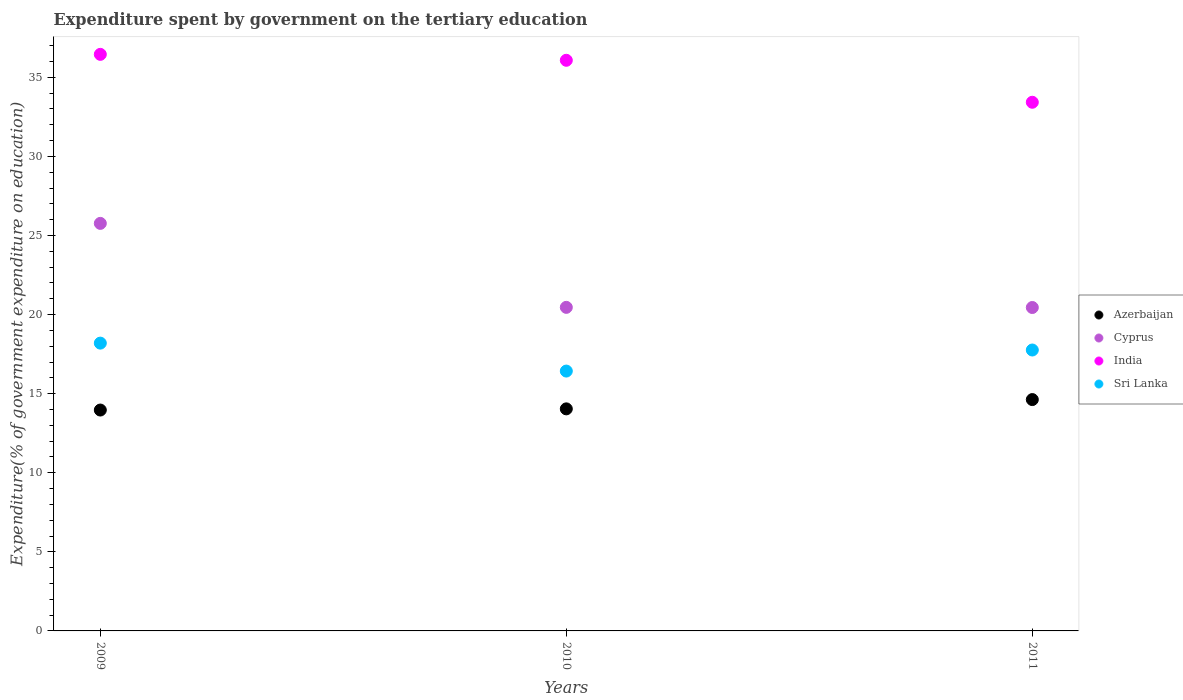Is the number of dotlines equal to the number of legend labels?
Offer a very short reply. Yes. What is the expenditure spent by government on the tertiary education in India in 2009?
Offer a very short reply. 36.45. Across all years, what is the maximum expenditure spent by government on the tertiary education in India?
Your answer should be compact. 36.45. Across all years, what is the minimum expenditure spent by government on the tertiary education in India?
Give a very brief answer. 33.42. In which year was the expenditure spent by government on the tertiary education in Azerbaijan maximum?
Provide a succinct answer. 2011. What is the total expenditure spent by government on the tertiary education in Cyprus in the graph?
Your answer should be compact. 66.67. What is the difference between the expenditure spent by government on the tertiary education in India in 2009 and that in 2010?
Provide a succinct answer. 0.37. What is the difference between the expenditure spent by government on the tertiary education in Azerbaijan in 2011 and the expenditure spent by government on the tertiary education in India in 2010?
Make the answer very short. -21.45. What is the average expenditure spent by government on the tertiary education in Azerbaijan per year?
Ensure brevity in your answer.  14.21. In the year 2009, what is the difference between the expenditure spent by government on the tertiary education in Azerbaijan and expenditure spent by government on the tertiary education in Sri Lanka?
Provide a short and direct response. -4.23. In how many years, is the expenditure spent by government on the tertiary education in Cyprus greater than 6 %?
Your answer should be very brief. 3. What is the ratio of the expenditure spent by government on the tertiary education in Cyprus in 2009 to that in 2010?
Provide a succinct answer. 1.26. What is the difference between the highest and the second highest expenditure spent by government on the tertiary education in India?
Ensure brevity in your answer.  0.37. What is the difference between the highest and the lowest expenditure spent by government on the tertiary education in Azerbaijan?
Your answer should be very brief. 0.66. Is the sum of the expenditure spent by government on the tertiary education in Cyprus in 2009 and 2010 greater than the maximum expenditure spent by government on the tertiary education in Sri Lanka across all years?
Your answer should be compact. Yes. Is it the case that in every year, the sum of the expenditure spent by government on the tertiary education in Azerbaijan and expenditure spent by government on the tertiary education in Sri Lanka  is greater than the expenditure spent by government on the tertiary education in Cyprus?
Offer a very short reply. Yes. Does the expenditure spent by government on the tertiary education in India monotonically increase over the years?
Offer a terse response. No. Does the graph contain any zero values?
Your response must be concise. No. Does the graph contain grids?
Your answer should be very brief. No. What is the title of the graph?
Ensure brevity in your answer.  Expenditure spent by government on the tertiary education. What is the label or title of the X-axis?
Your response must be concise. Years. What is the label or title of the Y-axis?
Ensure brevity in your answer.  Expenditure(% of government expenditure on education). What is the Expenditure(% of government expenditure on education) in Azerbaijan in 2009?
Offer a very short reply. 13.96. What is the Expenditure(% of government expenditure on education) in Cyprus in 2009?
Offer a terse response. 25.77. What is the Expenditure(% of government expenditure on education) in India in 2009?
Provide a succinct answer. 36.45. What is the Expenditure(% of government expenditure on education) of Sri Lanka in 2009?
Make the answer very short. 18.19. What is the Expenditure(% of government expenditure on education) of Azerbaijan in 2010?
Keep it short and to the point. 14.04. What is the Expenditure(% of government expenditure on education) of Cyprus in 2010?
Make the answer very short. 20.46. What is the Expenditure(% of government expenditure on education) in India in 2010?
Offer a terse response. 36.08. What is the Expenditure(% of government expenditure on education) in Sri Lanka in 2010?
Your answer should be very brief. 16.43. What is the Expenditure(% of government expenditure on education) of Azerbaijan in 2011?
Provide a succinct answer. 14.63. What is the Expenditure(% of government expenditure on education) in Cyprus in 2011?
Your response must be concise. 20.45. What is the Expenditure(% of government expenditure on education) in India in 2011?
Your answer should be very brief. 33.42. What is the Expenditure(% of government expenditure on education) of Sri Lanka in 2011?
Offer a terse response. 17.76. Across all years, what is the maximum Expenditure(% of government expenditure on education) in Azerbaijan?
Offer a very short reply. 14.63. Across all years, what is the maximum Expenditure(% of government expenditure on education) of Cyprus?
Make the answer very short. 25.77. Across all years, what is the maximum Expenditure(% of government expenditure on education) of India?
Give a very brief answer. 36.45. Across all years, what is the maximum Expenditure(% of government expenditure on education) in Sri Lanka?
Your answer should be compact. 18.19. Across all years, what is the minimum Expenditure(% of government expenditure on education) of Azerbaijan?
Offer a terse response. 13.96. Across all years, what is the minimum Expenditure(% of government expenditure on education) in Cyprus?
Your response must be concise. 20.45. Across all years, what is the minimum Expenditure(% of government expenditure on education) in India?
Your answer should be very brief. 33.42. Across all years, what is the minimum Expenditure(% of government expenditure on education) in Sri Lanka?
Give a very brief answer. 16.43. What is the total Expenditure(% of government expenditure on education) of Azerbaijan in the graph?
Keep it short and to the point. 42.63. What is the total Expenditure(% of government expenditure on education) in Cyprus in the graph?
Your response must be concise. 66.67. What is the total Expenditure(% of government expenditure on education) of India in the graph?
Offer a terse response. 105.95. What is the total Expenditure(% of government expenditure on education) in Sri Lanka in the graph?
Your response must be concise. 52.38. What is the difference between the Expenditure(% of government expenditure on education) in Azerbaijan in 2009 and that in 2010?
Offer a very short reply. -0.07. What is the difference between the Expenditure(% of government expenditure on education) in Cyprus in 2009 and that in 2010?
Provide a short and direct response. 5.31. What is the difference between the Expenditure(% of government expenditure on education) of India in 2009 and that in 2010?
Offer a terse response. 0.37. What is the difference between the Expenditure(% of government expenditure on education) in Sri Lanka in 2009 and that in 2010?
Provide a short and direct response. 1.77. What is the difference between the Expenditure(% of government expenditure on education) of Azerbaijan in 2009 and that in 2011?
Offer a very short reply. -0.66. What is the difference between the Expenditure(% of government expenditure on education) in Cyprus in 2009 and that in 2011?
Offer a very short reply. 5.32. What is the difference between the Expenditure(% of government expenditure on education) of India in 2009 and that in 2011?
Keep it short and to the point. 3.03. What is the difference between the Expenditure(% of government expenditure on education) of Sri Lanka in 2009 and that in 2011?
Provide a short and direct response. 0.44. What is the difference between the Expenditure(% of government expenditure on education) of Azerbaijan in 2010 and that in 2011?
Your answer should be very brief. -0.59. What is the difference between the Expenditure(% of government expenditure on education) of Cyprus in 2010 and that in 2011?
Your response must be concise. 0.01. What is the difference between the Expenditure(% of government expenditure on education) of India in 2010 and that in 2011?
Keep it short and to the point. 2.65. What is the difference between the Expenditure(% of government expenditure on education) of Sri Lanka in 2010 and that in 2011?
Provide a succinct answer. -1.33. What is the difference between the Expenditure(% of government expenditure on education) of Azerbaijan in 2009 and the Expenditure(% of government expenditure on education) of Cyprus in 2010?
Keep it short and to the point. -6.49. What is the difference between the Expenditure(% of government expenditure on education) of Azerbaijan in 2009 and the Expenditure(% of government expenditure on education) of India in 2010?
Your answer should be compact. -22.11. What is the difference between the Expenditure(% of government expenditure on education) in Azerbaijan in 2009 and the Expenditure(% of government expenditure on education) in Sri Lanka in 2010?
Ensure brevity in your answer.  -2.46. What is the difference between the Expenditure(% of government expenditure on education) in Cyprus in 2009 and the Expenditure(% of government expenditure on education) in India in 2010?
Offer a terse response. -10.31. What is the difference between the Expenditure(% of government expenditure on education) of Cyprus in 2009 and the Expenditure(% of government expenditure on education) of Sri Lanka in 2010?
Make the answer very short. 9.34. What is the difference between the Expenditure(% of government expenditure on education) of India in 2009 and the Expenditure(% of government expenditure on education) of Sri Lanka in 2010?
Make the answer very short. 20.02. What is the difference between the Expenditure(% of government expenditure on education) of Azerbaijan in 2009 and the Expenditure(% of government expenditure on education) of Cyprus in 2011?
Your answer should be very brief. -6.48. What is the difference between the Expenditure(% of government expenditure on education) in Azerbaijan in 2009 and the Expenditure(% of government expenditure on education) in India in 2011?
Your response must be concise. -19.46. What is the difference between the Expenditure(% of government expenditure on education) of Azerbaijan in 2009 and the Expenditure(% of government expenditure on education) of Sri Lanka in 2011?
Keep it short and to the point. -3.8. What is the difference between the Expenditure(% of government expenditure on education) of Cyprus in 2009 and the Expenditure(% of government expenditure on education) of India in 2011?
Ensure brevity in your answer.  -7.66. What is the difference between the Expenditure(% of government expenditure on education) in Cyprus in 2009 and the Expenditure(% of government expenditure on education) in Sri Lanka in 2011?
Provide a succinct answer. 8.01. What is the difference between the Expenditure(% of government expenditure on education) of India in 2009 and the Expenditure(% of government expenditure on education) of Sri Lanka in 2011?
Offer a very short reply. 18.69. What is the difference between the Expenditure(% of government expenditure on education) of Azerbaijan in 2010 and the Expenditure(% of government expenditure on education) of Cyprus in 2011?
Offer a very short reply. -6.41. What is the difference between the Expenditure(% of government expenditure on education) of Azerbaijan in 2010 and the Expenditure(% of government expenditure on education) of India in 2011?
Provide a succinct answer. -19.38. What is the difference between the Expenditure(% of government expenditure on education) of Azerbaijan in 2010 and the Expenditure(% of government expenditure on education) of Sri Lanka in 2011?
Offer a very short reply. -3.72. What is the difference between the Expenditure(% of government expenditure on education) of Cyprus in 2010 and the Expenditure(% of government expenditure on education) of India in 2011?
Your response must be concise. -12.97. What is the difference between the Expenditure(% of government expenditure on education) of Cyprus in 2010 and the Expenditure(% of government expenditure on education) of Sri Lanka in 2011?
Offer a terse response. 2.7. What is the difference between the Expenditure(% of government expenditure on education) of India in 2010 and the Expenditure(% of government expenditure on education) of Sri Lanka in 2011?
Your response must be concise. 18.32. What is the average Expenditure(% of government expenditure on education) of Azerbaijan per year?
Give a very brief answer. 14.21. What is the average Expenditure(% of government expenditure on education) in Cyprus per year?
Your answer should be compact. 22.22. What is the average Expenditure(% of government expenditure on education) in India per year?
Your response must be concise. 35.32. What is the average Expenditure(% of government expenditure on education) of Sri Lanka per year?
Your answer should be very brief. 17.46. In the year 2009, what is the difference between the Expenditure(% of government expenditure on education) in Azerbaijan and Expenditure(% of government expenditure on education) in Cyprus?
Your answer should be compact. -11.8. In the year 2009, what is the difference between the Expenditure(% of government expenditure on education) of Azerbaijan and Expenditure(% of government expenditure on education) of India?
Offer a terse response. -22.49. In the year 2009, what is the difference between the Expenditure(% of government expenditure on education) in Azerbaijan and Expenditure(% of government expenditure on education) in Sri Lanka?
Provide a short and direct response. -4.23. In the year 2009, what is the difference between the Expenditure(% of government expenditure on education) in Cyprus and Expenditure(% of government expenditure on education) in India?
Offer a terse response. -10.69. In the year 2009, what is the difference between the Expenditure(% of government expenditure on education) in Cyprus and Expenditure(% of government expenditure on education) in Sri Lanka?
Offer a very short reply. 7.57. In the year 2009, what is the difference between the Expenditure(% of government expenditure on education) of India and Expenditure(% of government expenditure on education) of Sri Lanka?
Ensure brevity in your answer.  18.26. In the year 2010, what is the difference between the Expenditure(% of government expenditure on education) in Azerbaijan and Expenditure(% of government expenditure on education) in Cyprus?
Offer a very short reply. -6.42. In the year 2010, what is the difference between the Expenditure(% of government expenditure on education) of Azerbaijan and Expenditure(% of government expenditure on education) of India?
Your answer should be very brief. -22.04. In the year 2010, what is the difference between the Expenditure(% of government expenditure on education) in Azerbaijan and Expenditure(% of government expenditure on education) in Sri Lanka?
Give a very brief answer. -2.39. In the year 2010, what is the difference between the Expenditure(% of government expenditure on education) of Cyprus and Expenditure(% of government expenditure on education) of India?
Offer a terse response. -15.62. In the year 2010, what is the difference between the Expenditure(% of government expenditure on education) in Cyprus and Expenditure(% of government expenditure on education) in Sri Lanka?
Provide a succinct answer. 4.03. In the year 2010, what is the difference between the Expenditure(% of government expenditure on education) of India and Expenditure(% of government expenditure on education) of Sri Lanka?
Your response must be concise. 19.65. In the year 2011, what is the difference between the Expenditure(% of government expenditure on education) of Azerbaijan and Expenditure(% of government expenditure on education) of Cyprus?
Keep it short and to the point. -5.82. In the year 2011, what is the difference between the Expenditure(% of government expenditure on education) in Azerbaijan and Expenditure(% of government expenditure on education) in India?
Ensure brevity in your answer.  -18.8. In the year 2011, what is the difference between the Expenditure(% of government expenditure on education) of Azerbaijan and Expenditure(% of government expenditure on education) of Sri Lanka?
Ensure brevity in your answer.  -3.13. In the year 2011, what is the difference between the Expenditure(% of government expenditure on education) of Cyprus and Expenditure(% of government expenditure on education) of India?
Provide a short and direct response. -12.98. In the year 2011, what is the difference between the Expenditure(% of government expenditure on education) in Cyprus and Expenditure(% of government expenditure on education) in Sri Lanka?
Make the answer very short. 2.69. In the year 2011, what is the difference between the Expenditure(% of government expenditure on education) in India and Expenditure(% of government expenditure on education) in Sri Lanka?
Provide a short and direct response. 15.66. What is the ratio of the Expenditure(% of government expenditure on education) in Azerbaijan in 2009 to that in 2010?
Offer a very short reply. 0.99. What is the ratio of the Expenditure(% of government expenditure on education) of Cyprus in 2009 to that in 2010?
Make the answer very short. 1.26. What is the ratio of the Expenditure(% of government expenditure on education) in India in 2009 to that in 2010?
Your answer should be very brief. 1.01. What is the ratio of the Expenditure(% of government expenditure on education) of Sri Lanka in 2009 to that in 2010?
Your response must be concise. 1.11. What is the ratio of the Expenditure(% of government expenditure on education) of Azerbaijan in 2009 to that in 2011?
Give a very brief answer. 0.95. What is the ratio of the Expenditure(% of government expenditure on education) of Cyprus in 2009 to that in 2011?
Keep it short and to the point. 1.26. What is the ratio of the Expenditure(% of government expenditure on education) of India in 2009 to that in 2011?
Ensure brevity in your answer.  1.09. What is the ratio of the Expenditure(% of government expenditure on education) of Sri Lanka in 2009 to that in 2011?
Provide a short and direct response. 1.02. What is the ratio of the Expenditure(% of government expenditure on education) in Azerbaijan in 2010 to that in 2011?
Ensure brevity in your answer.  0.96. What is the ratio of the Expenditure(% of government expenditure on education) in India in 2010 to that in 2011?
Ensure brevity in your answer.  1.08. What is the ratio of the Expenditure(% of government expenditure on education) of Sri Lanka in 2010 to that in 2011?
Your response must be concise. 0.93. What is the difference between the highest and the second highest Expenditure(% of government expenditure on education) in Azerbaijan?
Provide a short and direct response. 0.59. What is the difference between the highest and the second highest Expenditure(% of government expenditure on education) of Cyprus?
Your response must be concise. 5.31. What is the difference between the highest and the second highest Expenditure(% of government expenditure on education) of India?
Give a very brief answer. 0.37. What is the difference between the highest and the second highest Expenditure(% of government expenditure on education) in Sri Lanka?
Offer a very short reply. 0.44. What is the difference between the highest and the lowest Expenditure(% of government expenditure on education) in Azerbaijan?
Your answer should be very brief. 0.66. What is the difference between the highest and the lowest Expenditure(% of government expenditure on education) of Cyprus?
Provide a short and direct response. 5.32. What is the difference between the highest and the lowest Expenditure(% of government expenditure on education) in India?
Make the answer very short. 3.03. What is the difference between the highest and the lowest Expenditure(% of government expenditure on education) of Sri Lanka?
Offer a terse response. 1.77. 